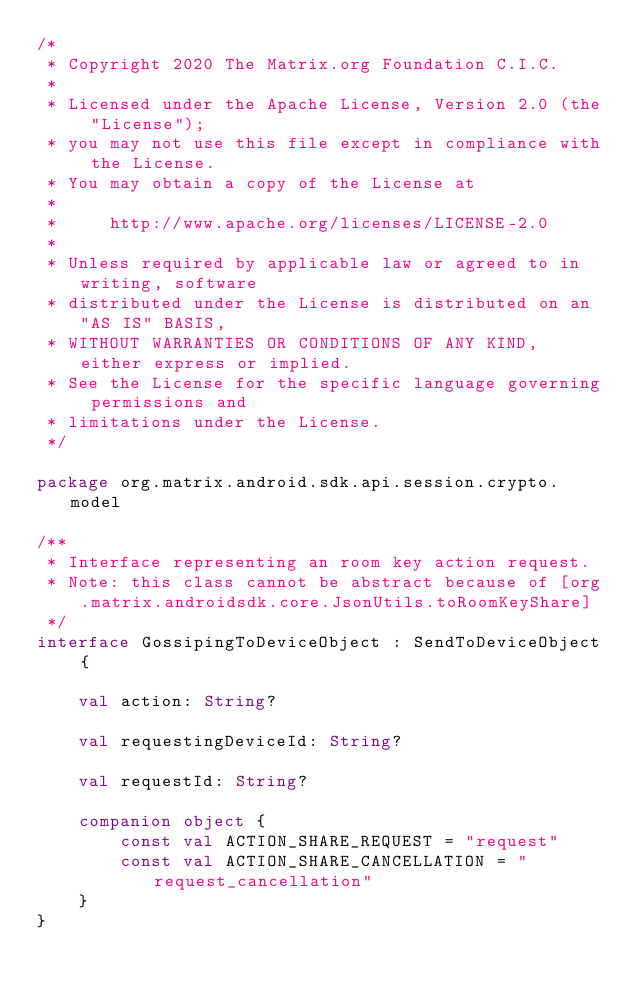<code> <loc_0><loc_0><loc_500><loc_500><_Kotlin_>/*
 * Copyright 2020 The Matrix.org Foundation C.I.C.
 *
 * Licensed under the Apache License, Version 2.0 (the "License");
 * you may not use this file except in compliance with the License.
 * You may obtain a copy of the License at
 *
 *     http://www.apache.org/licenses/LICENSE-2.0
 *
 * Unless required by applicable law or agreed to in writing, software
 * distributed under the License is distributed on an "AS IS" BASIS,
 * WITHOUT WARRANTIES OR CONDITIONS OF ANY KIND, either express or implied.
 * See the License for the specific language governing permissions and
 * limitations under the License.
 */

package org.matrix.android.sdk.api.session.crypto.model

/**
 * Interface representing an room key action request.
 * Note: this class cannot be abstract because of [org.matrix.androidsdk.core.JsonUtils.toRoomKeyShare]
 */
interface GossipingToDeviceObject : SendToDeviceObject {

    val action: String?

    val requestingDeviceId: String?

    val requestId: String?

    companion object {
        const val ACTION_SHARE_REQUEST = "request"
        const val ACTION_SHARE_CANCELLATION = "request_cancellation"
    }
}
</code> 